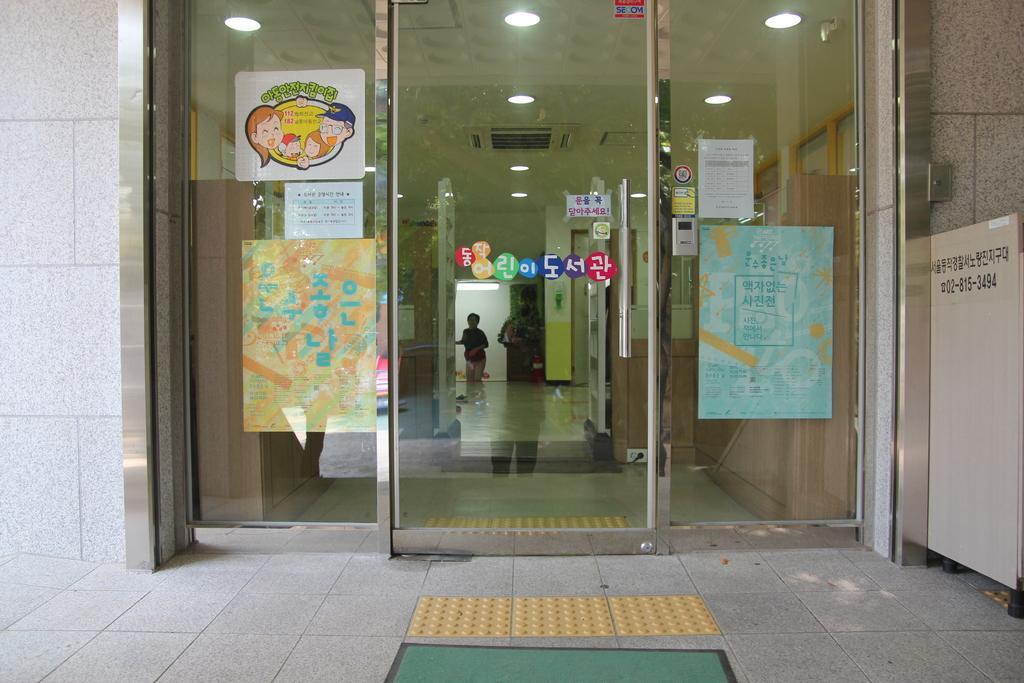Can you describe this image briefly? In this image I can see the glass door and the board. I can see the papers and posters attached to the glass door. Inside the building I can see the person and there are lights at the top. I can see the reflection of one person on the glass. 